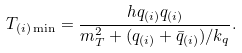<formula> <loc_0><loc_0><loc_500><loc_500>T _ { ( i ) \min } = \frac { h q _ { ( i ) } q _ { ( i ) } } { m _ { T } ^ { 2 } + ( q _ { ( i ) } + \bar { q } _ { ( i ) } ) / k _ { q } } .</formula> 